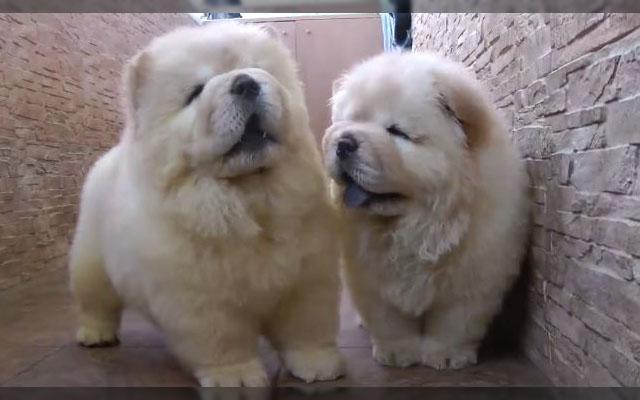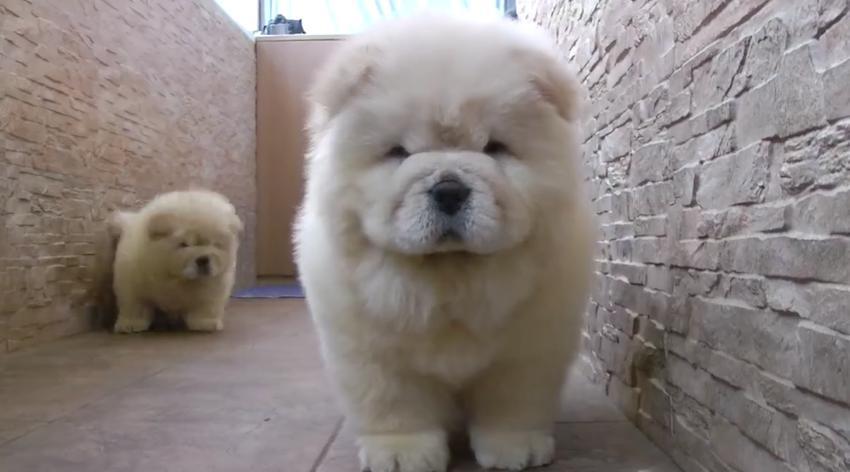The first image is the image on the left, the second image is the image on the right. Analyze the images presented: Is the assertion "THere are exactly two dogs in the image on the left." valid? Answer yes or no. Yes. The first image is the image on the left, the second image is the image on the right. Considering the images on both sides, is "An image shows two chow puppies side by side between stone walls." valid? Answer yes or no. Yes. 